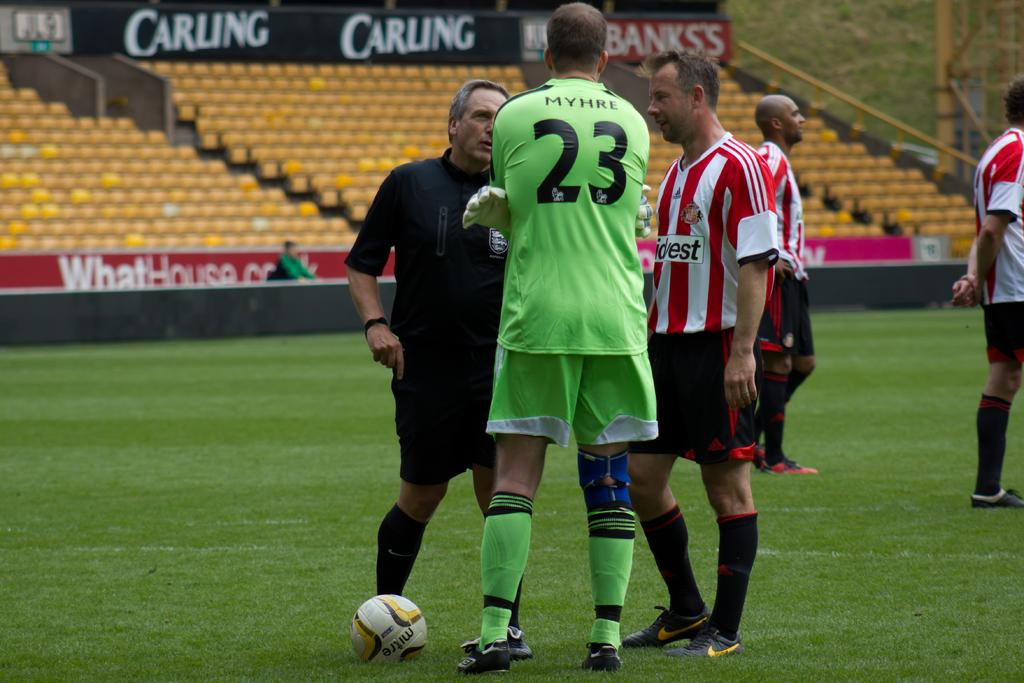<image>
Describe the image concisely. Soccer player number 23 speaks to his coach and the referee on a field sponsored by Carling. 